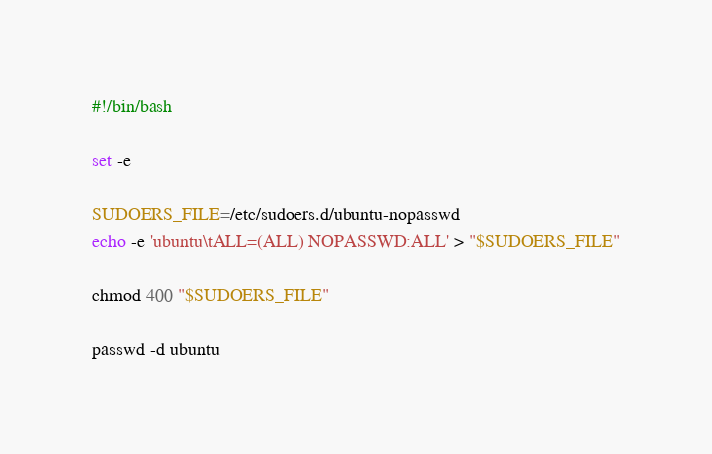Convert code to text. <code><loc_0><loc_0><loc_500><loc_500><_Bash_>#!/bin/bash

set -e

SUDOERS_FILE=/etc/sudoers.d/ubuntu-nopasswd
echo -e 'ubuntu\tALL=(ALL) NOPASSWD:ALL' > "$SUDOERS_FILE"

chmod 400 "$SUDOERS_FILE"

passwd -d ubuntu
</code> 